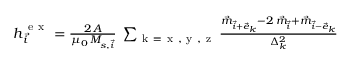<formula> <loc_0><loc_0><loc_500><loc_500>\begin{array} { r } { h _ { \vec { i } } ^ { e x } = \frac { 2 \, A } { \mu _ { 0 } \, M _ { s , \vec { i } } } \, \sum _ { k = x , y , z } \frac { \vec { m } _ { \vec { i } + \vec { e } _ { k } } - 2 \, \vec { m } _ { \vec { i } } + \vec { m } _ { \vec { i } - \vec { e } _ { k } } } { \Delta _ { k } ^ { 2 } } } \end{array}</formula> 